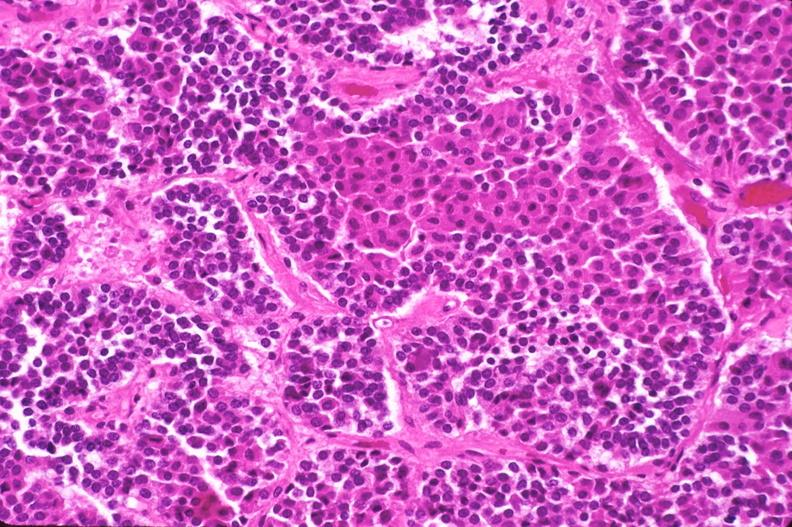s endocrine present?
Answer the question using a single word or phrase. Yes 